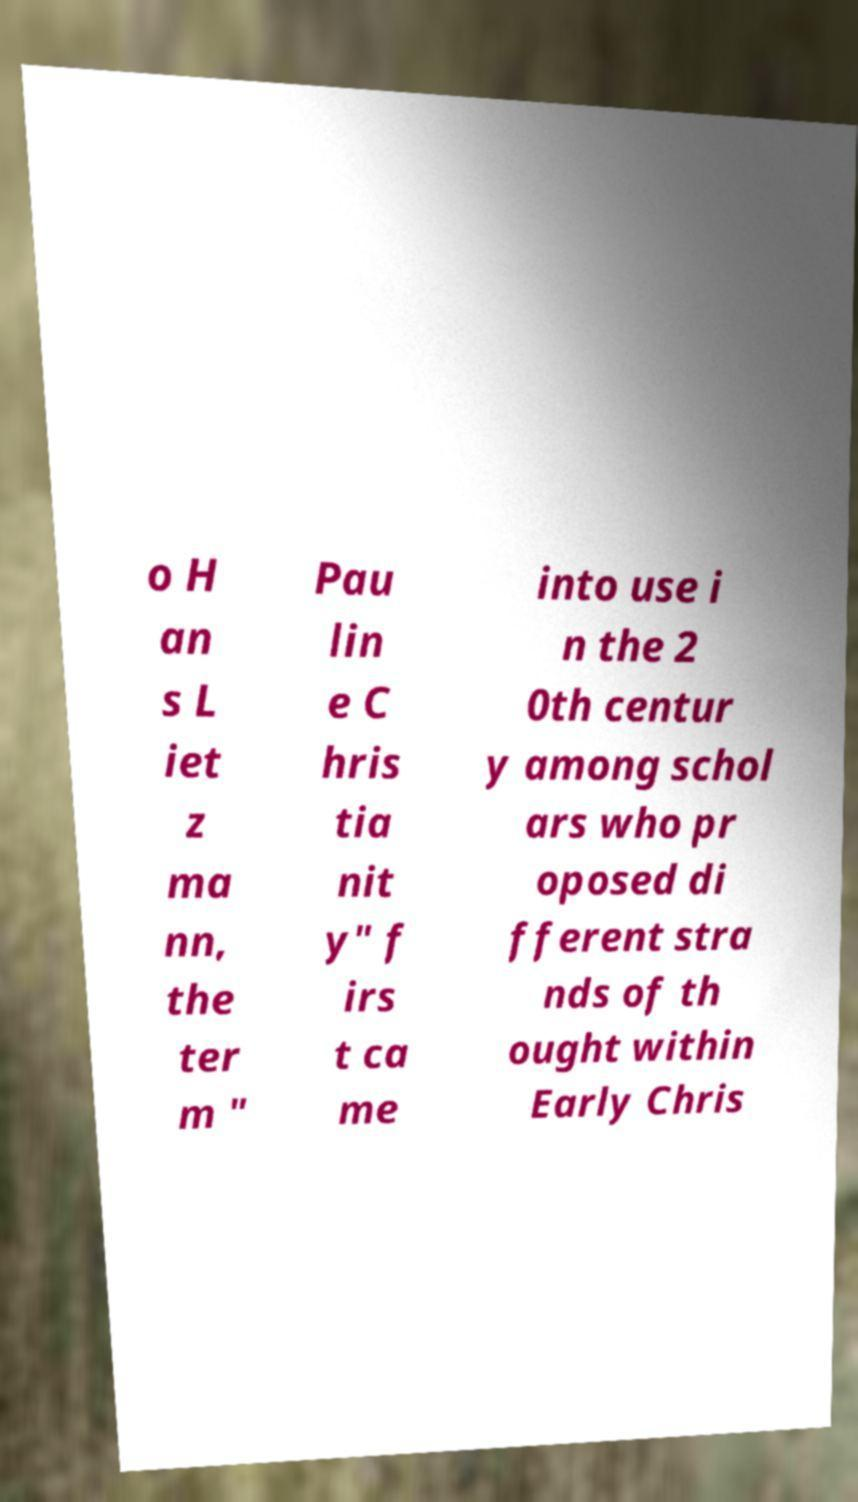There's text embedded in this image that I need extracted. Can you transcribe it verbatim? o H an s L iet z ma nn, the ter m " Pau lin e C hris tia nit y" f irs t ca me into use i n the 2 0th centur y among schol ars who pr oposed di fferent stra nds of th ought within Early Chris 